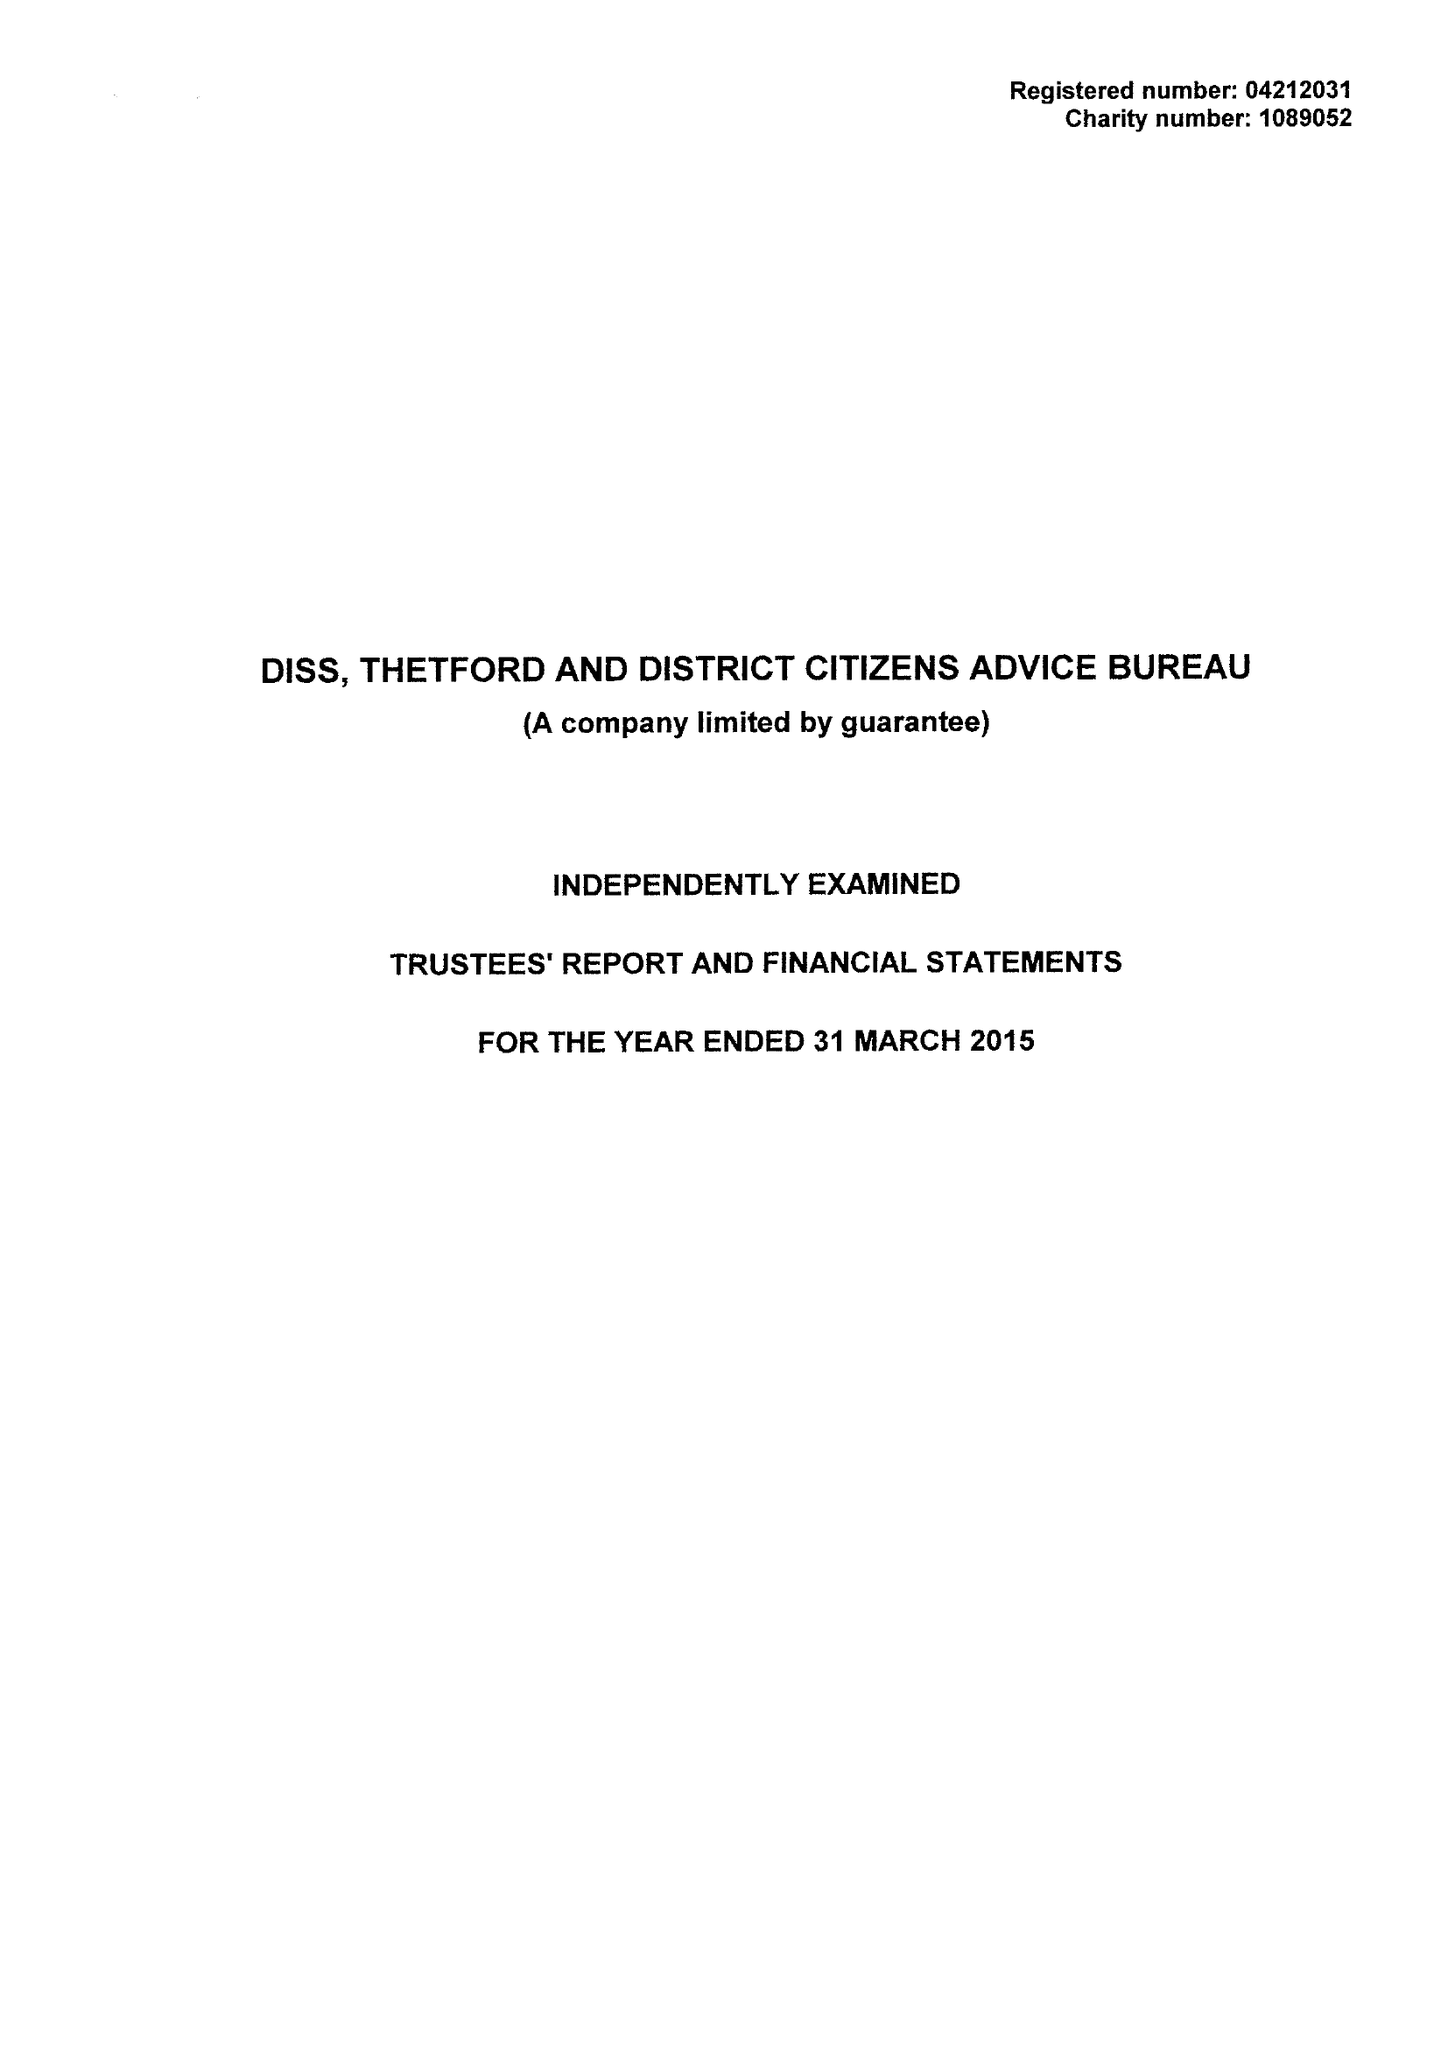What is the value for the address__street_line?
Answer the question using a single word or phrase. SHELFANGER ROAD 